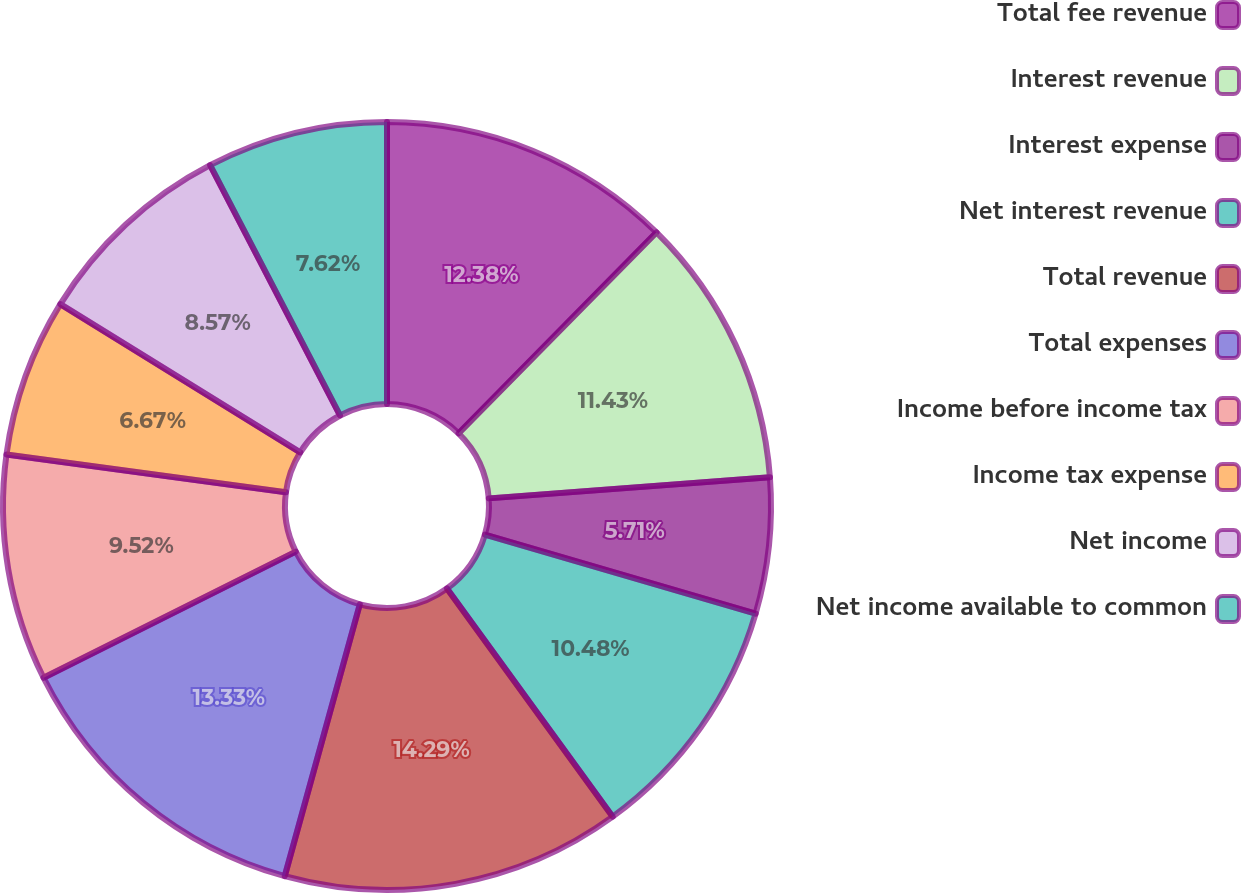<chart> <loc_0><loc_0><loc_500><loc_500><pie_chart><fcel>Total fee revenue<fcel>Interest revenue<fcel>Interest expense<fcel>Net interest revenue<fcel>Total revenue<fcel>Total expenses<fcel>Income before income tax<fcel>Income tax expense<fcel>Net income<fcel>Net income available to common<nl><fcel>12.38%<fcel>11.43%<fcel>5.71%<fcel>10.48%<fcel>14.29%<fcel>13.33%<fcel>9.52%<fcel>6.67%<fcel>8.57%<fcel>7.62%<nl></chart> 